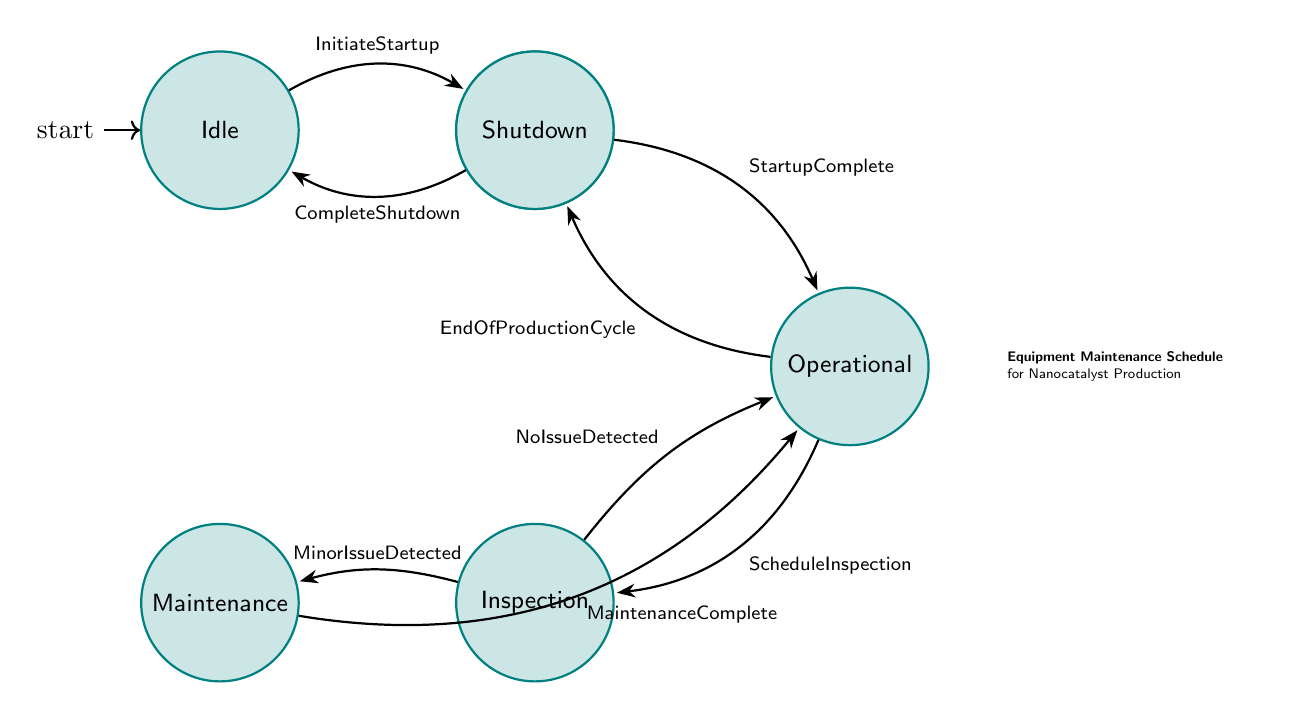What is the initial state of the system? The system begins in the "Idle" state as indicated by the initial node marked in the diagram.
Answer: Idle How many states are there in total? The diagram shows six distinct states: Idle, Startup, Operational, Inspection, Maintenance, and Shutdown. Counting these gives a total of six states.
Answer: 6 What triggers the transition from Operational to Inspection? The transition from Operational to Inspection is triggered by the "ScheduleInspection" event as shown on the corresponding edge connecting these nodes.
Answer: ScheduleInspection What is the next state after Maintenance is complete? Once maintenance is completed, the transition confirms that the next state is "Operational," as indicated on the edge leading from Maintenance to Operational.
Answer: Operational What happens to the system after an EndOfProductionCycle? The system transitions from Operational to Shutdown following the "EndOfProductionCycle" trigger, which specifies that production has concluded.
Answer: Shutdown In which state would the system perform equipment inspections? The system is in the "Inspection" state during scheduled inspections, as labeled in that node of the diagram.
Answer: Inspection What occurs if a MinorIssueDetected during the Inspection phase? If a minor issue is detected during the Inspection, the system transitions to the "Maintenance" state, as shown by the directed edge between Inspection and Maintenance.
Answer: Maintenance What is the final state after completing the shutdown process? Once the shutdown process is complete, the system transitions to the "Idle" state, as defined by the edge leading from Shutdown to Idle.
Answer: Idle 